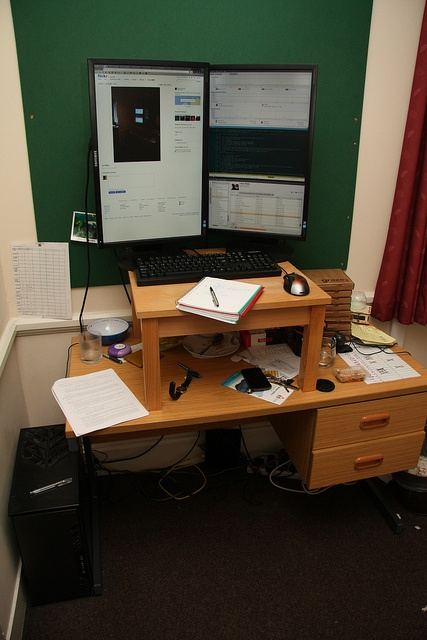Describe the objects in this image and their specific colors. I can see tv in tan, darkgray, black, and gray tones, tv in tan, black, and gray tones, tv in tan, gray, and black tones, keyboard in tan, black, gray, and maroon tones, and book in tan, ivory, darkgray, lightgray, and brown tones in this image. 